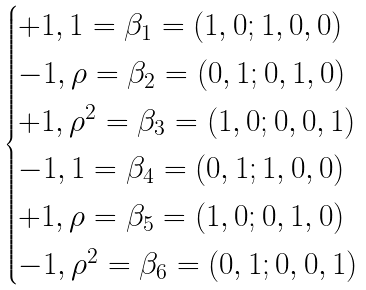<formula> <loc_0><loc_0><loc_500><loc_500>\begin{cases} + 1 , 1 = \beta _ { 1 } = ( 1 , 0 ; 1 , 0 , 0 ) \\ - 1 , \rho = \beta _ { 2 } = ( 0 , 1 ; 0 , 1 , 0 ) \\ + 1 , \rho ^ { 2 } = \beta _ { 3 } = ( 1 , 0 ; 0 , 0 , 1 ) \\ - 1 , 1 = \beta _ { 4 } = ( 0 , 1 ; 1 , 0 , 0 ) \\ + 1 , \rho = \beta _ { 5 } = ( 1 , 0 ; 0 , 1 , 0 ) \\ - 1 , \rho ^ { 2 } = \beta _ { 6 } = ( 0 , 1 ; 0 , 0 , 1 ) \end{cases}</formula> 